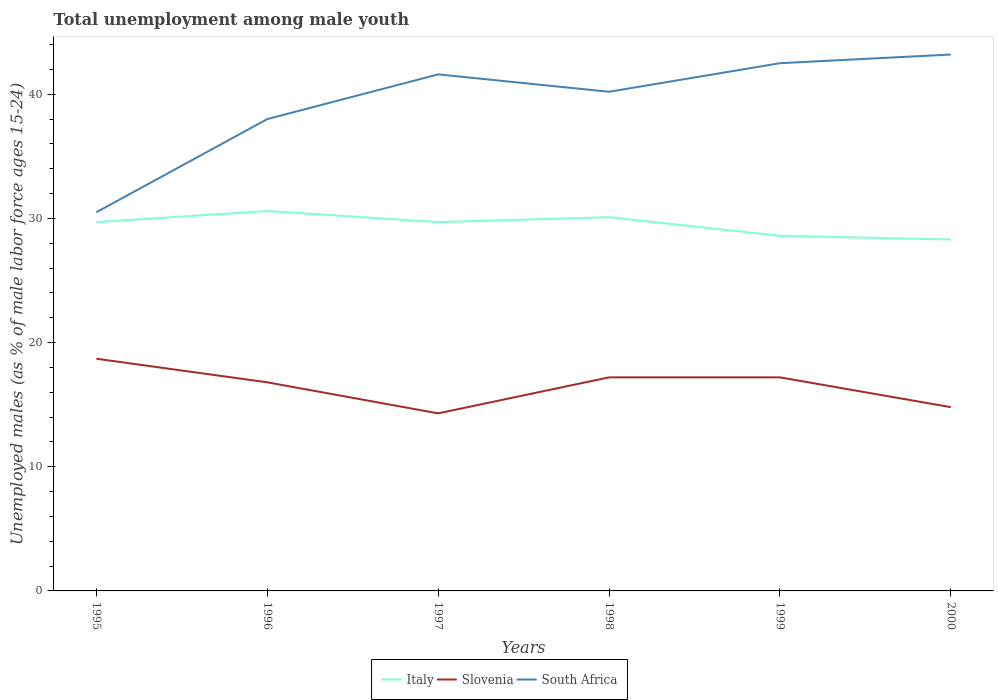How many different coloured lines are there?
Your answer should be compact. 3. Does the line corresponding to Italy intersect with the line corresponding to Slovenia?
Make the answer very short. No. Is the number of lines equal to the number of legend labels?
Your response must be concise. Yes. Across all years, what is the maximum percentage of unemployed males in in Italy?
Your answer should be compact. 28.3. In which year was the percentage of unemployed males in in Slovenia maximum?
Make the answer very short. 1997. What is the total percentage of unemployed males in in South Africa in the graph?
Offer a very short reply. -11.1. What is the difference between the highest and the second highest percentage of unemployed males in in Slovenia?
Give a very brief answer. 4.4. What is the difference between the highest and the lowest percentage of unemployed males in in Slovenia?
Give a very brief answer. 4. How many lines are there?
Your response must be concise. 3. What is the title of the graph?
Give a very brief answer. Total unemployment among male youth. Does "Norway" appear as one of the legend labels in the graph?
Offer a terse response. No. What is the label or title of the Y-axis?
Ensure brevity in your answer.  Unemployed males (as % of male labor force ages 15-24). What is the Unemployed males (as % of male labor force ages 15-24) in Italy in 1995?
Your answer should be compact. 29.7. What is the Unemployed males (as % of male labor force ages 15-24) of Slovenia in 1995?
Your answer should be compact. 18.7. What is the Unemployed males (as % of male labor force ages 15-24) in South Africa in 1995?
Keep it short and to the point. 30.5. What is the Unemployed males (as % of male labor force ages 15-24) in Italy in 1996?
Your answer should be compact. 30.6. What is the Unemployed males (as % of male labor force ages 15-24) in Slovenia in 1996?
Provide a succinct answer. 16.8. What is the Unemployed males (as % of male labor force ages 15-24) of South Africa in 1996?
Provide a succinct answer. 38. What is the Unemployed males (as % of male labor force ages 15-24) in Italy in 1997?
Give a very brief answer. 29.7. What is the Unemployed males (as % of male labor force ages 15-24) of Slovenia in 1997?
Your response must be concise. 14.3. What is the Unemployed males (as % of male labor force ages 15-24) in South Africa in 1997?
Your answer should be very brief. 41.6. What is the Unemployed males (as % of male labor force ages 15-24) of Italy in 1998?
Make the answer very short. 30.1. What is the Unemployed males (as % of male labor force ages 15-24) of Slovenia in 1998?
Your response must be concise. 17.2. What is the Unemployed males (as % of male labor force ages 15-24) in South Africa in 1998?
Offer a terse response. 40.2. What is the Unemployed males (as % of male labor force ages 15-24) of Italy in 1999?
Your answer should be very brief. 28.6. What is the Unemployed males (as % of male labor force ages 15-24) of Slovenia in 1999?
Offer a terse response. 17.2. What is the Unemployed males (as % of male labor force ages 15-24) of South Africa in 1999?
Your response must be concise. 42.5. What is the Unemployed males (as % of male labor force ages 15-24) of Italy in 2000?
Offer a terse response. 28.3. What is the Unemployed males (as % of male labor force ages 15-24) of Slovenia in 2000?
Provide a short and direct response. 14.8. What is the Unemployed males (as % of male labor force ages 15-24) in South Africa in 2000?
Your answer should be very brief. 43.2. Across all years, what is the maximum Unemployed males (as % of male labor force ages 15-24) in Italy?
Your answer should be very brief. 30.6. Across all years, what is the maximum Unemployed males (as % of male labor force ages 15-24) in Slovenia?
Offer a very short reply. 18.7. Across all years, what is the maximum Unemployed males (as % of male labor force ages 15-24) in South Africa?
Give a very brief answer. 43.2. Across all years, what is the minimum Unemployed males (as % of male labor force ages 15-24) in Italy?
Offer a terse response. 28.3. Across all years, what is the minimum Unemployed males (as % of male labor force ages 15-24) in Slovenia?
Ensure brevity in your answer.  14.3. Across all years, what is the minimum Unemployed males (as % of male labor force ages 15-24) of South Africa?
Keep it short and to the point. 30.5. What is the total Unemployed males (as % of male labor force ages 15-24) in Italy in the graph?
Give a very brief answer. 177. What is the total Unemployed males (as % of male labor force ages 15-24) of South Africa in the graph?
Your answer should be compact. 236. What is the difference between the Unemployed males (as % of male labor force ages 15-24) of Slovenia in 1995 and that in 1996?
Provide a short and direct response. 1.9. What is the difference between the Unemployed males (as % of male labor force ages 15-24) of South Africa in 1995 and that in 1997?
Your answer should be compact. -11.1. What is the difference between the Unemployed males (as % of male labor force ages 15-24) in Italy in 1995 and that in 1998?
Offer a terse response. -0.4. What is the difference between the Unemployed males (as % of male labor force ages 15-24) of South Africa in 1995 and that in 1998?
Ensure brevity in your answer.  -9.7. What is the difference between the Unemployed males (as % of male labor force ages 15-24) of Slovenia in 1995 and that in 1999?
Provide a succinct answer. 1.5. What is the difference between the Unemployed males (as % of male labor force ages 15-24) in South Africa in 1995 and that in 1999?
Provide a succinct answer. -12. What is the difference between the Unemployed males (as % of male labor force ages 15-24) of Slovenia in 1995 and that in 2000?
Give a very brief answer. 3.9. What is the difference between the Unemployed males (as % of male labor force ages 15-24) of South Africa in 1995 and that in 2000?
Ensure brevity in your answer.  -12.7. What is the difference between the Unemployed males (as % of male labor force ages 15-24) of South Africa in 1996 and that in 1997?
Your response must be concise. -3.6. What is the difference between the Unemployed males (as % of male labor force ages 15-24) of South Africa in 1996 and that in 1999?
Make the answer very short. -4.5. What is the difference between the Unemployed males (as % of male labor force ages 15-24) of Italy in 1997 and that in 1998?
Your answer should be very brief. -0.4. What is the difference between the Unemployed males (as % of male labor force ages 15-24) in South Africa in 1997 and that in 2000?
Your answer should be compact. -1.6. What is the difference between the Unemployed males (as % of male labor force ages 15-24) of Italy in 1998 and that in 1999?
Make the answer very short. 1.5. What is the difference between the Unemployed males (as % of male labor force ages 15-24) in Slovenia in 1998 and that in 1999?
Your answer should be compact. 0. What is the difference between the Unemployed males (as % of male labor force ages 15-24) of South Africa in 1998 and that in 1999?
Offer a very short reply. -2.3. What is the difference between the Unemployed males (as % of male labor force ages 15-24) of Italy in 1998 and that in 2000?
Provide a succinct answer. 1.8. What is the difference between the Unemployed males (as % of male labor force ages 15-24) of Slovenia in 1998 and that in 2000?
Your answer should be very brief. 2.4. What is the difference between the Unemployed males (as % of male labor force ages 15-24) of Italy in 1999 and that in 2000?
Your answer should be very brief. 0.3. What is the difference between the Unemployed males (as % of male labor force ages 15-24) in Slovenia in 1999 and that in 2000?
Make the answer very short. 2.4. What is the difference between the Unemployed males (as % of male labor force ages 15-24) in Italy in 1995 and the Unemployed males (as % of male labor force ages 15-24) in Slovenia in 1996?
Provide a succinct answer. 12.9. What is the difference between the Unemployed males (as % of male labor force ages 15-24) in Italy in 1995 and the Unemployed males (as % of male labor force ages 15-24) in South Africa in 1996?
Ensure brevity in your answer.  -8.3. What is the difference between the Unemployed males (as % of male labor force ages 15-24) in Slovenia in 1995 and the Unemployed males (as % of male labor force ages 15-24) in South Africa in 1996?
Provide a short and direct response. -19.3. What is the difference between the Unemployed males (as % of male labor force ages 15-24) in Italy in 1995 and the Unemployed males (as % of male labor force ages 15-24) in South Africa in 1997?
Your answer should be compact. -11.9. What is the difference between the Unemployed males (as % of male labor force ages 15-24) of Slovenia in 1995 and the Unemployed males (as % of male labor force ages 15-24) of South Africa in 1997?
Offer a terse response. -22.9. What is the difference between the Unemployed males (as % of male labor force ages 15-24) in Italy in 1995 and the Unemployed males (as % of male labor force ages 15-24) in Slovenia in 1998?
Make the answer very short. 12.5. What is the difference between the Unemployed males (as % of male labor force ages 15-24) in Italy in 1995 and the Unemployed males (as % of male labor force ages 15-24) in South Africa in 1998?
Your answer should be compact. -10.5. What is the difference between the Unemployed males (as % of male labor force ages 15-24) in Slovenia in 1995 and the Unemployed males (as % of male labor force ages 15-24) in South Africa in 1998?
Provide a succinct answer. -21.5. What is the difference between the Unemployed males (as % of male labor force ages 15-24) in Slovenia in 1995 and the Unemployed males (as % of male labor force ages 15-24) in South Africa in 1999?
Provide a short and direct response. -23.8. What is the difference between the Unemployed males (as % of male labor force ages 15-24) in Slovenia in 1995 and the Unemployed males (as % of male labor force ages 15-24) in South Africa in 2000?
Your answer should be very brief. -24.5. What is the difference between the Unemployed males (as % of male labor force ages 15-24) of Italy in 1996 and the Unemployed males (as % of male labor force ages 15-24) of Slovenia in 1997?
Keep it short and to the point. 16.3. What is the difference between the Unemployed males (as % of male labor force ages 15-24) in Slovenia in 1996 and the Unemployed males (as % of male labor force ages 15-24) in South Africa in 1997?
Make the answer very short. -24.8. What is the difference between the Unemployed males (as % of male labor force ages 15-24) of Italy in 1996 and the Unemployed males (as % of male labor force ages 15-24) of South Africa in 1998?
Provide a short and direct response. -9.6. What is the difference between the Unemployed males (as % of male labor force ages 15-24) of Slovenia in 1996 and the Unemployed males (as % of male labor force ages 15-24) of South Africa in 1998?
Keep it short and to the point. -23.4. What is the difference between the Unemployed males (as % of male labor force ages 15-24) in Italy in 1996 and the Unemployed males (as % of male labor force ages 15-24) in Slovenia in 1999?
Your answer should be very brief. 13.4. What is the difference between the Unemployed males (as % of male labor force ages 15-24) of Slovenia in 1996 and the Unemployed males (as % of male labor force ages 15-24) of South Africa in 1999?
Ensure brevity in your answer.  -25.7. What is the difference between the Unemployed males (as % of male labor force ages 15-24) of Italy in 1996 and the Unemployed males (as % of male labor force ages 15-24) of Slovenia in 2000?
Your response must be concise. 15.8. What is the difference between the Unemployed males (as % of male labor force ages 15-24) in Slovenia in 1996 and the Unemployed males (as % of male labor force ages 15-24) in South Africa in 2000?
Provide a short and direct response. -26.4. What is the difference between the Unemployed males (as % of male labor force ages 15-24) in Italy in 1997 and the Unemployed males (as % of male labor force ages 15-24) in South Africa in 1998?
Your response must be concise. -10.5. What is the difference between the Unemployed males (as % of male labor force ages 15-24) of Slovenia in 1997 and the Unemployed males (as % of male labor force ages 15-24) of South Africa in 1998?
Offer a very short reply. -25.9. What is the difference between the Unemployed males (as % of male labor force ages 15-24) in Slovenia in 1997 and the Unemployed males (as % of male labor force ages 15-24) in South Africa in 1999?
Give a very brief answer. -28.2. What is the difference between the Unemployed males (as % of male labor force ages 15-24) of Slovenia in 1997 and the Unemployed males (as % of male labor force ages 15-24) of South Africa in 2000?
Your response must be concise. -28.9. What is the difference between the Unemployed males (as % of male labor force ages 15-24) of Italy in 1998 and the Unemployed males (as % of male labor force ages 15-24) of Slovenia in 1999?
Provide a succinct answer. 12.9. What is the difference between the Unemployed males (as % of male labor force ages 15-24) of Italy in 1998 and the Unemployed males (as % of male labor force ages 15-24) of South Africa in 1999?
Provide a short and direct response. -12.4. What is the difference between the Unemployed males (as % of male labor force ages 15-24) in Slovenia in 1998 and the Unemployed males (as % of male labor force ages 15-24) in South Africa in 1999?
Your answer should be very brief. -25.3. What is the difference between the Unemployed males (as % of male labor force ages 15-24) of Italy in 1998 and the Unemployed males (as % of male labor force ages 15-24) of Slovenia in 2000?
Make the answer very short. 15.3. What is the difference between the Unemployed males (as % of male labor force ages 15-24) in Slovenia in 1998 and the Unemployed males (as % of male labor force ages 15-24) in South Africa in 2000?
Your answer should be compact. -26. What is the difference between the Unemployed males (as % of male labor force ages 15-24) in Italy in 1999 and the Unemployed males (as % of male labor force ages 15-24) in South Africa in 2000?
Give a very brief answer. -14.6. What is the average Unemployed males (as % of male labor force ages 15-24) of Italy per year?
Offer a terse response. 29.5. What is the average Unemployed males (as % of male labor force ages 15-24) of Slovenia per year?
Keep it short and to the point. 16.5. What is the average Unemployed males (as % of male labor force ages 15-24) in South Africa per year?
Provide a short and direct response. 39.33. In the year 1995, what is the difference between the Unemployed males (as % of male labor force ages 15-24) of Slovenia and Unemployed males (as % of male labor force ages 15-24) of South Africa?
Make the answer very short. -11.8. In the year 1996, what is the difference between the Unemployed males (as % of male labor force ages 15-24) in Slovenia and Unemployed males (as % of male labor force ages 15-24) in South Africa?
Offer a very short reply. -21.2. In the year 1997, what is the difference between the Unemployed males (as % of male labor force ages 15-24) of Italy and Unemployed males (as % of male labor force ages 15-24) of Slovenia?
Provide a short and direct response. 15.4. In the year 1997, what is the difference between the Unemployed males (as % of male labor force ages 15-24) of Italy and Unemployed males (as % of male labor force ages 15-24) of South Africa?
Your answer should be compact. -11.9. In the year 1997, what is the difference between the Unemployed males (as % of male labor force ages 15-24) in Slovenia and Unemployed males (as % of male labor force ages 15-24) in South Africa?
Your answer should be compact. -27.3. In the year 1998, what is the difference between the Unemployed males (as % of male labor force ages 15-24) in Italy and Unemployed males (as % of male labor force ages 15-24) in South Africa?
Offer a very short reply. -10.1. In the year 1999, what is the difference between the Unemployed males (as % of male labor force ages 15-24) in Slovenia and Unemployed males (as % of male labor force ages 15-24) in South Africa?
Provide a succinct answer. -25.3. In the year 2000, what is the difference between the Unemployed males (as % of male labor force ages 15-24) of Italy and Unemployed males (as % of male labor force ages 15-24) of South Africa?
Ensure brevity in your answer.  -14.9. In the year 2000, what is the difference between the Unemployed males (as % of male labor force ages 15-24) in Slovenia and Unemployed males (as % of male labor force ages 15-24) in South Africa?
Offer a terse response. -28.4. What is the ratio of the Unemployed males (as % of male labor force ages 15-24) of Italy in 1995 to that in 1996?
Give a very brief answer. 0.97. What is the ratio of the Unemployed males (as % of male labor force ages 15-24) of Slovenia in 1995 to that in 1996?
Provide a succinct answer. 1.11. What is the ratio of the Unemployed males (as % of male labor force ages 15-24) in South Africa in 1995 to that in 1996?
Your response must be concise. 0.8. What is the ratio of the Unemployed males (as % of male labor force ages 15-24) of Slovenia in 1995 to that in 1997?
Provide a short and direct response. 1.31. What is the ratio of the Unemployed males (as % of male labor force ages 15-24) in South Africa in 1995 to that in 1997?
Ensure brevity in your answer.  0.73. What is the ratio of the Unemployed males (as % of male labor force ages 15-24) in Italy in 1995 to that in 1998?
Offer a terse response. 0.99. What is the ratio of the Unemployed males (as % of male labor force ages 15-24) of Slovenia in 1995 to that in 1998?
Provide a succinct answer. 1.09. What is the ratio of the Unemployed males (as % of male labor force ages 15-24) in South Africa in 1995 to that in 1998?
Give a very brief answer. 0.76. What is the ratio of the Unemployed males (as % of male labor force ages 15-24) of Slovenia in 1995 to that in 1999?
Keep it short and to the point. 1.09. What is the ratio of the Unemployed males (as % of male labor force ages 15-24) of South Africa in 1995 to that in 1999?
Offer a terse response. 0.72. What is the ratio of the Unemployed males (as % of male labor force ages 15-24) in Italy in 1995 to that in 2000?
Give a very brief answer. 1.05. What is the ratio of the Unemployed males (as % of male labor force ages 15-24) of Slovenia in 1995 to that in 2000?
Your answer should be compact. 1.26. What is the ratio of the Unemployed males (as % of male labor force ages 15-24) of South Africa in 1995 to that in 2000?
Provide a succinct answer. 0.71. What is the ratio of the Unemployed males (as % of male labor force ages 15-24) of Italy in 1996 to that in 1997?
Provide a succinct answer. 1.03. What is the ratio of the Unemployed males (as % of male labor force ages 15-24) of Slovenia in 1996 to that in 1997?
Provide a succinct answer. 1.17. What is the ratio of the Unemployed males (as % of male labor force ages 15-24) of South Africa in 1996 to that in 1997?
Your answer should be compact. 0.91. What is the ratio of the Unemployed males (as % of male labor force ages 15-24) in Italy in 1996 to that in 1998?
Your response must be concise. 1.02. What is the ratio of the Unemployed males (as % of male labor force ages 15-24) in Slovenia in 1996 to that in 1998?
Offer a very short reply. 0.98. What is the ratio of the Unemployed males (as % of male labor force ages 15-24) of South Africa in 1996 to that in 1998?
Provide a short and direct response. 0.95. What is the ratio of the Unemployed males (as % of male labor force ages 15-24) in Italy in 1996 to that in 1999?
Your answer should be very brief. 1.07. What is the ratio of the Unemployed males (as % of male labor force ages 15-24) of Slovenia in 1996 to that in 1999?
Provide a succinct answer. 0.98. What is the ratio of the Unemployed males (as % of male labor force ages 15-24) of South Africa in 1996 to that in 1999?
Provide a short and direct response. 0.89. What is the ratio of the Unemployed males (as % of male labor force ages 15-24) of Italy in 1996 to that in 2000?
Make the answer very short. 1.08. What is the ratio of the Unemployed males (as % of male labor force ages 15-24) of Slovenia in 1996 to that in 2000?
Ensure brevity in your answer.  1.14. What is the ratio of the Unemployed males (as % of male labor force ages 15-24) of South Africa in 1996 to that in 2000?
Give a very brief answer. 0.88. What is the ratio of the Unemployed males (as % of male labor force ages 15-24) in Italy in 1997 to that in 1998?
Offer a terse response. 0.99. What is the ratio of the Unemployed males (as % of male labor force ages 15-24) in Slovenia in 1997 to that in 1998?
Give a very brief answer. 0.83. What is the ratio of the Unemployed males (as % of male labor force ages 15-24) of South Africa in 1997 to that in 1998?
Provide a succinct answer. 1.03. What is the ratio of the Unemployed males (as % of male labor force ages 15-24) in Slovenia in 1997 to that in 1999?
Offer a very short reply. 0.83. What is the ratio of the Unemployed males (as % of male labor force ages 15-24) in South Africa in 1997 to that in 1999?
Your answer should be compact. 0.98. What is the ratio of the Unemployed males (as % of male labor force ages 15-24) in Italy in 1997 to that in 2000?
Your response must be concise. 1.05. What is the ratio of the Unemployed males (as % of male labor force ages 15-24) of Slovenia in 1997 to that in 2000?
Your answer should be very brief. 0.97. What is the ratio of the Unemployed males (as % of male labor force ages 15-24) of Italy in 1998 to that in 1999?
Offer a very short reply. 1.05. What is the ratio of the Unemployed males (as % of male labor force ages 15-24) of Slovenia in 1998 to that in 1999?
Your answer should be compact. 1. What is the ratio of the Unemployed males (as % of male labor force ages 15-24) in South Africa in 1998 to that in 1999?
Provide a succinct answer. 0.95. What is the ratio of the Unemployed males (as % of male labor force ages 15-24) in Italy in 1998 to that in 2000?
Offer a very short reply. 1.06. What is the ratio of the Unemployed males (as % of male labor force ages 15-24) of Slovenia in 1998 to that in 2000?
Offer a terse response. 1.16. What is the ratio of the Unemployed males (as % of male labor force ages 15-24) of South Africa in 1998 to that in 2000?
Offer a very short reply. 0.93. What is the ratio of the Unemployed males (as % of male labor force ages 15-24) of Italy in 1999 to that in 2000?
Keep it short and to the point. 1.01. What is the ratio of the Unemployed males (as % of male labor force ages 15-24) of Slovenia in 1999 to that in 2000?
Provide a short and direct response. 1.16. What is the ratio of the Unemployed males (as % of male labor force ages 15-24) in South Africa in 1999 to that in 2000?
Keep it short and to the point. 0.98. What is the difference between the highest and the second highest Unemployed males (as % of male labor force ages 15-24) of Italy?
Make the answer very short. 0.5. What is the difference between the highest and the lowest Unemployed males (as % of male labor force ages 15-24) of Slovenia?
Your answer should be compact. 4.4. 